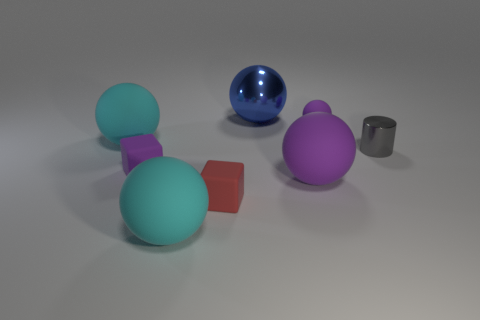There is a big cyan rubber thing behind the red cube; does it have the same shape as the big metallic object?
Keep it short and to the point. Yes. Are there fewer purple matte blocks than big cyan balls?
Provide a short and direct response. Yes. What number of metal spheres have the same color as the large metal thing?
Provide a short and direct response. 0. What material is the big thing that is the same color as the small matte ball?
Your answer should be compact. Rubber. There is a cylinder; is it the same color as the small rubber thing that is behind the small metal thing?
Keep it short and to the point. No. Are there more blue shiny cylinders than purple cubes?
Provide a short and direct response. No. There is another purple matte object that is the same shape as the large purple thing; what size is it?
Give a very brief answer. Small. Is the material of the small gray thing the same as the small purple thing that is to the right of the small purple block?
Your answer should be very brief. No. How many objects are purple matte spheres or red matte blocks?
Your answer should be compact. 3. There is a cyan rubber ball on the left side of the purple rubber block; does it have the same size as the metal object on the right side of the big blue shiny thing?
Give a very brief answer. No. 